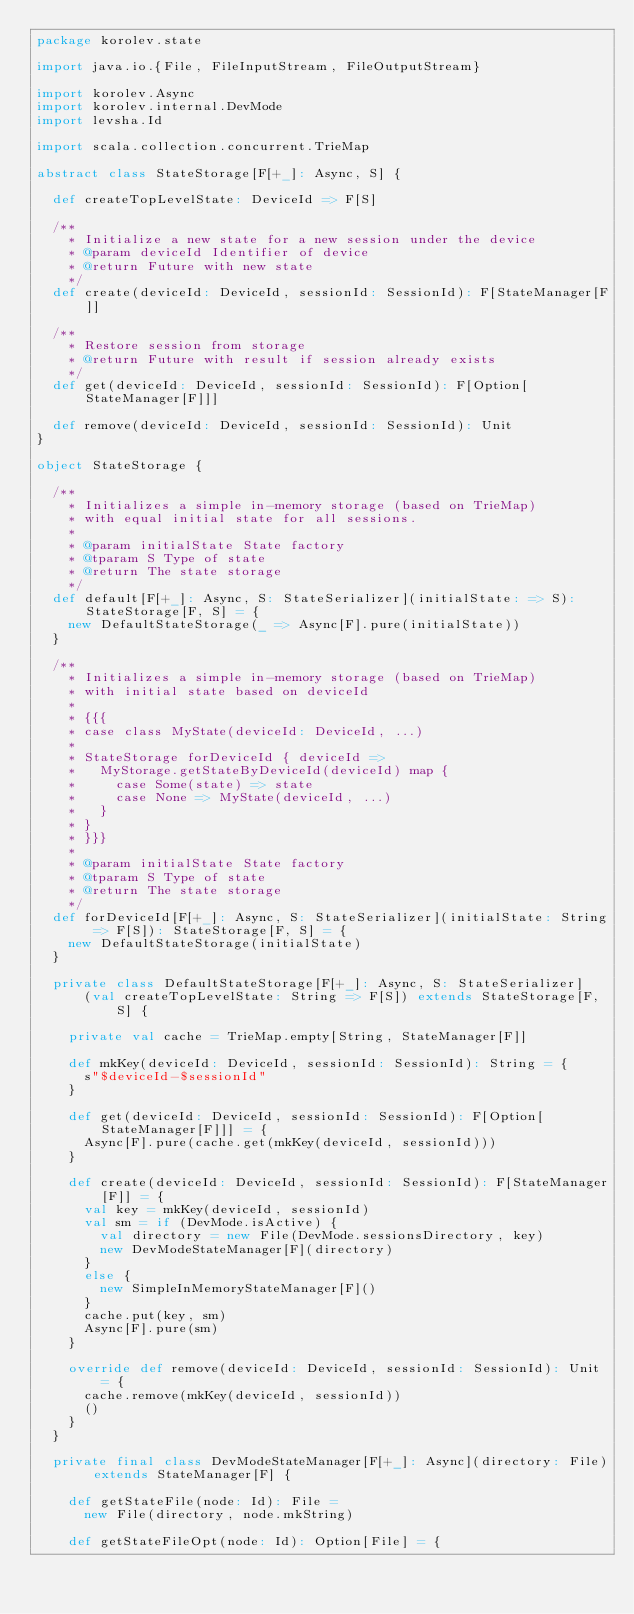<code> <loc_0><loc_0><loc_500><loc_500><_Scala_>package korolev.state

import java.io.{File, FileInputStream, FileOutputStream}

import korolev.Async
import korolev.internal.DevMode
import levsha.Id

import scala.collection.concurrent.TrieMap

abstract class StateStorage[F[+_]: Async, S] {

  def createTopLevelState: DeviceId => F[S]

  /**
    * Initialize a new state for a new session under the device
    * @param deviceId Identifier of device
    * @return Future with new state
    */
  def create(deviceId: DeviceId, sessionId: SessionId): F[StateManager[F]]

  /**
    * Restore session from storage
    * @return Future with result if session already exists
    */
  def get(deviceId: DeviceId, sessionId: SessionId): F[Option[StateManager[F]]]

  def remove(deviceId: DeviceId, sessionId: SessionId): Unit
}

object StateStorage {

  /**
    * Initializes a simple in-memory storage (based on TrieMap)
    * with equal initial state for all sessions.
    *
    * @param initialState State factory
    * @tparam S Type of state
    * @return The state storage
    */
  def default[F[+_]: Async, S: StateSerializer](initialState: => S): StateStorage[F, S] = {
    new DefaultStateStorage(_ => Async[F].pure(initialState))
  }

  /**
    * Initializes a simple in-memory storage (based on TrieMap)
    * with initial state based on deviceId
    *
    * {{{
    * case class MyState(deviceId: DeviceId, ...)
    *
    * StateStorage forDeviceId { deviceId =>
    *   MyStorage.getStateByDeviceId(deviceId) map {
    *     case Some(state) => state
    *     case None => MyState(deviceId, ...)
    *   }
    * }
    * }}}
    *
    * @param initialState State factory
    * @tparam S Type of state
    * @return The state storage
    */
  def forDeviceId[F[+_]: Async, S: StateSerializer](initialState: String => F[S]): StateStorage[F, S] = {
    new DefaultStateStorage(initialState)
  }

  private class DefaultStateStorage[F[+_]: Async, S: StateSerializer]
      (val createTopLevelState: String => F[S]) extends StateStorage[F, S] {

    private val cache = TrieMap.empty[String, StateManager[F]]

    def mkKey(deviceId: DeviceId, sessionId: SessionId): String = {
      s"$deviceId-$sessionId"
    }

    def get(deviceId: DeviceId, sessionId: SessionId): F[Option[StateManager[F]]] = {
      Async[F].pure(cache.get(mkKey(deviceId, sessionId)))
    }

    def create(deviceId: DeviceId, sessionId: SessionId): F[StateManager[F]] = {
      val key = mkKey(deviceId, sessionId)
      val sm = if (DevMode.isActive) {
        val directory = new File(DevMode.sessionsDirectory, key)
        new DevModeStateManager[F](directory)
      }
      else {
        new SimpleInMemoryStateManager[F]()
      }
      cache.put(key, sm)
      Async[F].pure(sm)
    }

    override def remove(deviceId: DeviceId, sessionId: SessionId): Unit = {
      cache.remove(mkKey(deviceId, sessionId))
      ()
    }
  }

  private final class DevModeStateManager[F[+_]: Async](directory: File) extends StateManager[F] {

    def getStateFile(node: Id): File =
      new File(directory, node.mkString)

    def getStateFileOpt(node: Id): Option[File] = {</code> 